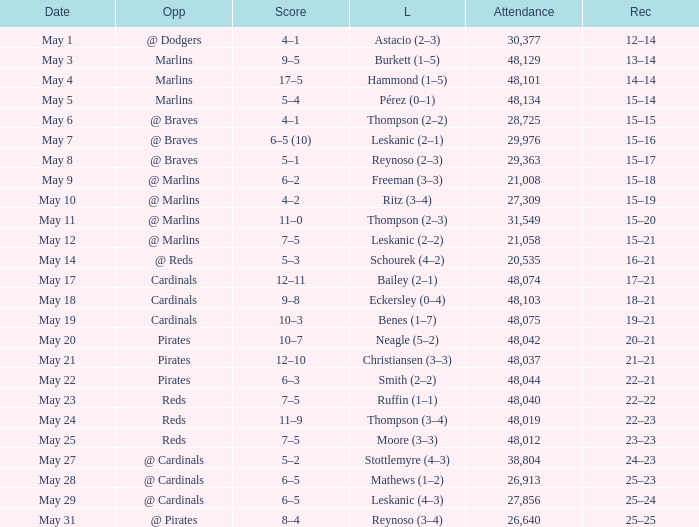Who did the Rockies play at the game that had a score of 6–5 (10)? @ Braves. 